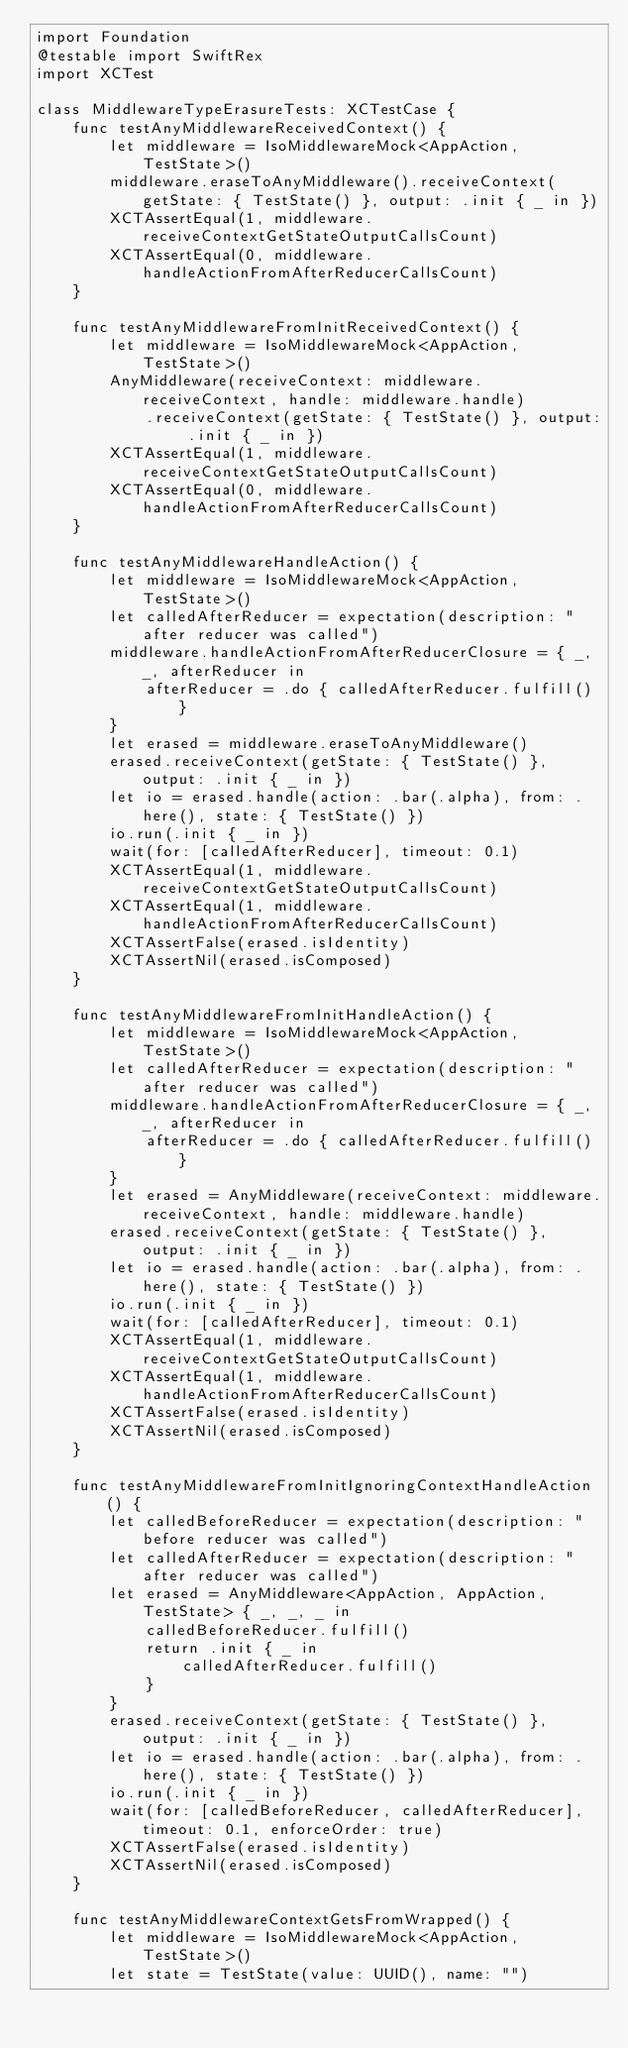<code> <loc_0><loc_0><loc_500><loc_500><_Swift_>import Foundation
@testable import SwiftRex
import XCTest

class MiddlewareTypeErasureTests: XCTestCase {
    func testAnyMiddlewareReceivedContext() {
        let middleware = IsoMiddlewareMock<AppAction, TestState>()
        middleware.eraseToAnyMiddleware().receiveContext(getState: { TestState() }, output: .init { _ in })
        XCTAssertEqual(1, middleware.receiveContextGetStateOutputCallsCount)
        XCTAssertEqual(0, middleware.handleActionFromAfterReducerCallsCount)
    }

    func testAnyMiddlewareFromInitReceivedContext() {
        let middleware = IsoMiddlewareMock<AppAction, TestState>()
        AnyMiddleware(receiveContext: middleware.receiveContext, handle: middleware.handle)
            .receiveContext(getState: { TestState() }, output: .init { _ in })
        XCTAssertEqual(1, middleware.receiveContextGetStateOutputCallsCount)
        XCTAssertEqual(0, middleware.handleActionFromAfterReducerCallsCount)
    }

    func testAnyMiddlewareHandleAction() {
        let middleware = IsoMiddlewareMock<AppAction, TestState>()
        let calledAfterReducer = expectation(description: "after reducer was called")
        middleware.handleActionFromAfterReducerClosure = { _, _, afterReducer in
            afterReducer = .do { calledAfterReducer.fulfill() }
        }
        let erased = middleware.eraseToAnyMiddleware()
        erased.receiveContext(getState: { TestState() }, output: .init { _ in })
        let io = erased.handle(action: .bar(.alpha), from: .here(), state: { TestState() })
        io.run(.init { _ in })
        wait(for: [calledAfterReducer], timeout: 0.1)
        XCTAssertEqual(1, middleware.receiveContextGetStateOutputCallsCount)
        XCTAssertEqual(1, middleware.handleActionFromAfterReducerCallsCount)
        XCTAssertFalse(erased.isIdentity)
        XCTAssertNil(erased.isComposed)
    }

    func testAnyMiddlewareFromInitHandleAction() {
        let middleware = IsoMiddlewareMock<AppAction, TestState>()
        let calledAfterReducer = expectation(description: "after reducer was called")
        middleware.handleActionFromAfterReducerClosure = { _, _, afterReducer in
            afterReducer = .do { calledAfterReducer.fulfill() }
        }
        let erased = AnyMiddleware(receiveContext: middleware.receiveContext, handle: middleware.handle)
        erased.receiveContext(getState: { TestState() }, output: .init { _ in })
        let io = erased.handle(action: .bar(.alpha), from: .here(), state: { TestState() })
        io.run(.init { _ in })
        wait(for: [calledAfterReducer], timeout: 0.1)
        XCTAssertEqual(1, middleware.receiveContextGetStateOutputCallsCount)
        XCTAssertEqual(1, middleware.handleActionFromAfterReducerCallsCount)
        XCTAssertFalse(erased.isIdentity)
        XCTAssertNil(erased.isComposed)
    }

    func testAnyMiddlewareFromInitIgnoringContextHandleAction() {
        let calledBeforeReducer = expectation(description: "before reducer was called")
        let calledAfterReducer = expectation(description: "after reducer was called")
        let erased = AnyMiddleware<AppAction, AppAction, TestState> { _, _, _ in
            calledBeforeReducer.fulfill()
            return .init { _ in
                calledAfterReducer.fulfill()
            }
        }
        erased.receiveContext(getState: { TestState() }, output: .init { _ in })
        let io = erased.handle(action: .bar(.alpha), from: .here(), state: { TestState() })
        io.run(.init { _ in })
        wait(for: [calledBeforeReducer, calledAfterReducer], timeout: 0.1, enforceOrder: true)
        XCTAssertFalse(erased.isIdentity)
        XCTAssertNil(erased.isComposed)
    }

    func testAnyMiddlewareContextGetsFromWrapped() {
        let middleware = IsoMiddlewareMock<AppAction, TestState>()
        let state = TestState(value: UUID(), name: "")</code> 